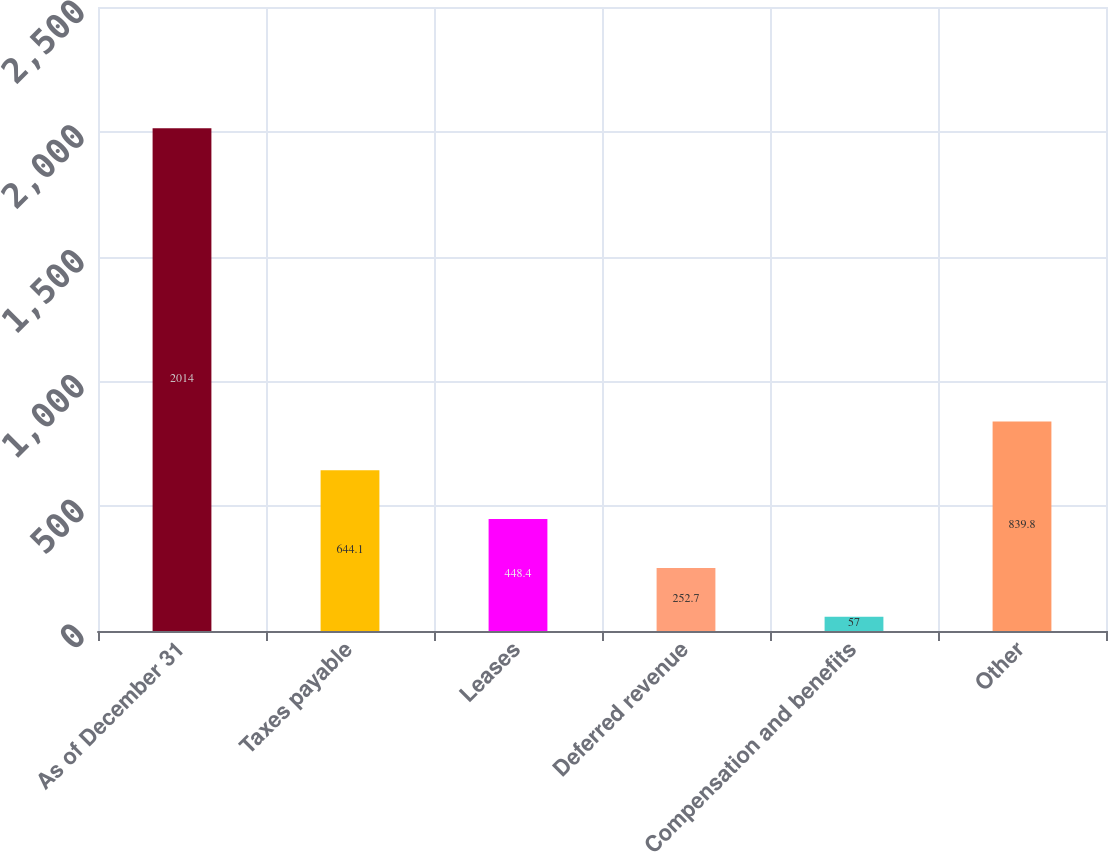Convert chart to OTSL. <chart><loc_0><loc_0><loc_500><loc_500><bar_chart><fcel>As of December 31<fcel>Taxes payable<fcel>Leases<fcel>Deferred revenue<fcel>Compensation and benefits<fcel>Other<nl><fcel>2014<fcel>644.1<fcel>448.4<fcel>252.7<fcel>57<fcel>839.8<nl></chart> 